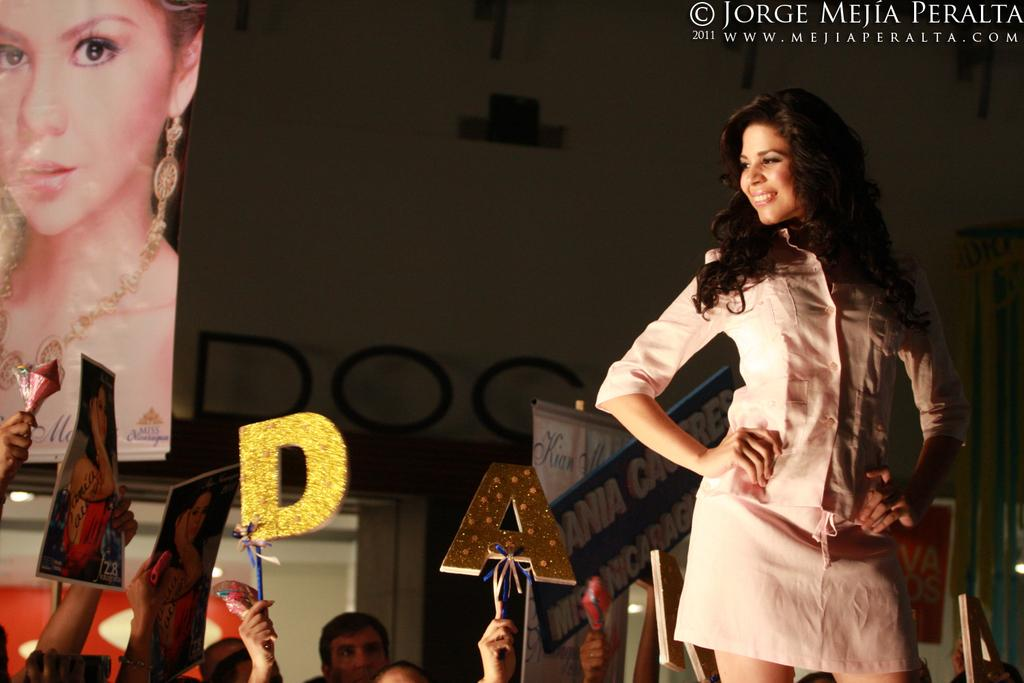What is the main subject of the image? There is a lady standing in the image. What can be seen in the background? In the background, there are people standing, and they are holding posters. What is the background setting like? There is a wall in the background. Is there any text visible in the image? Yes, there is some text visible in the top right corner of the image. What type of brick is being used to burn the wrench in the image? There is no brick, burning, or wrench present in the image. 